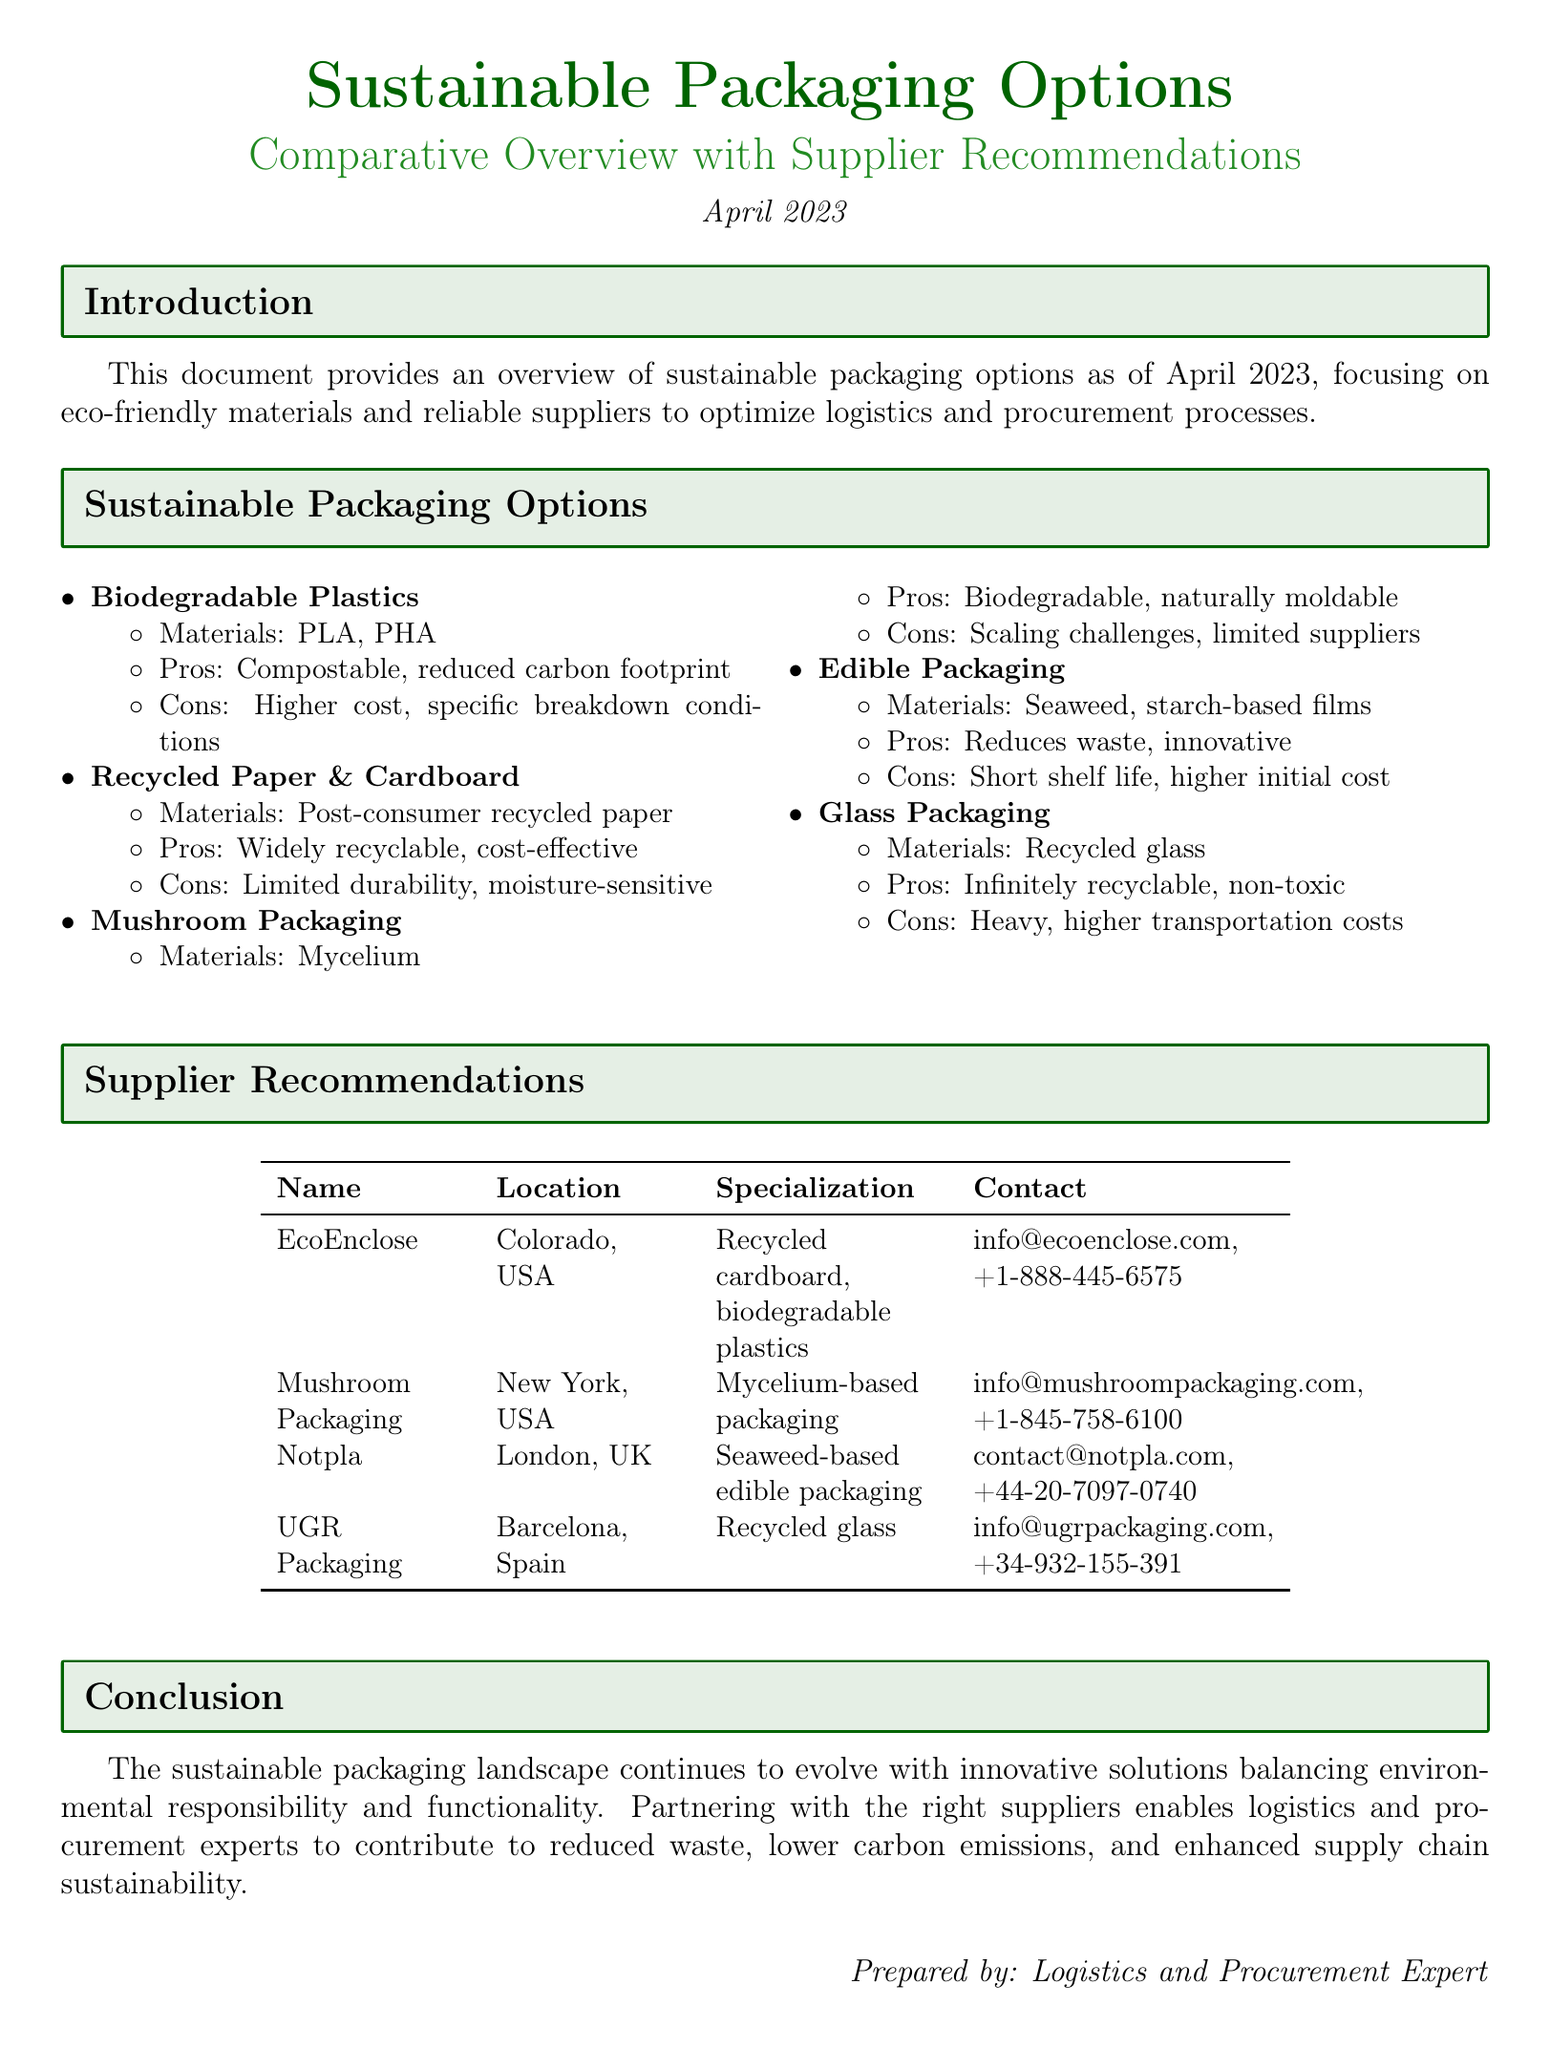what is the date of the document? The date is mentioned at the top of the document, indicating when it was prepared.
Answer: April 2023 what is one type of biodegradable plastic mentioned? The document lists biodegradable plastics and specifies examples of materials used.
Answer: PLA what is the location of EcoEnclose? The location of EcoEnclose is provided in the supplier recommendations section.
Answer: Colorado, USA which sustainable packaging option is described as "naturally moldable"? This refers to a specific type of sustainable packaging that's noted for its properties in the document.
Answer: Mushroom Packaging who specializes in seaweed-based edible packaging? The supplier recommendations section provides the name of the supplier focused on this type of packaging.
Answer: Notpla what are the two pros of recycled paper & cardboard? The document highlights the advantages of this material in the sustainable packaging section.
Answer: Widely recyclable, cost-effective which packaging material has higher initial cost and short shelf life? This question pertains to a specific type of sustainable packaging that has certain drawbacks as mentioned.
Answer: Edible Packaging how many suppliers are listed in the document? The document includes a table that outlines the recommended suppliers, allowing for a straightforward count.
Answer: Four 